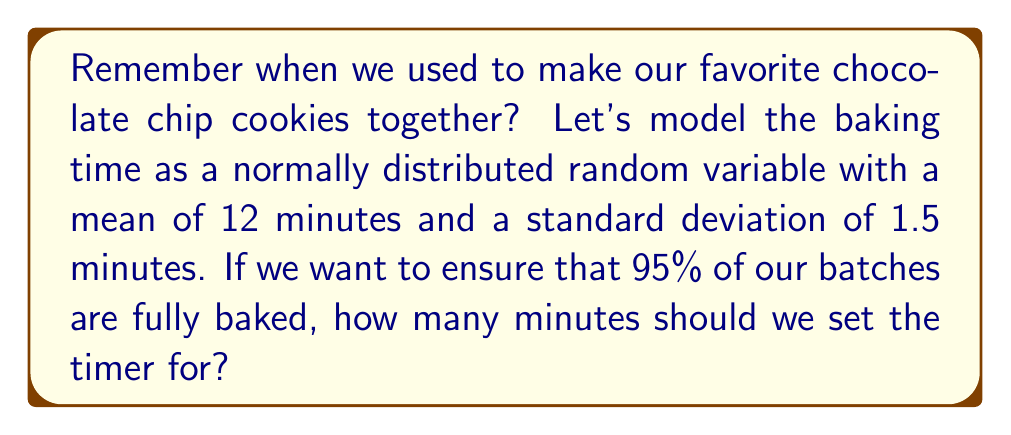Help me with this question. Let's approach this step-by-step:

1) We're dealing with a normal distribution where:
   $\mu = 12$ minutes (mean)
   $\sigma = 1.5$ minutes (standard deviation)

2) We want to find the time $t$ such that 95% of batches are fully baked. This means we're looking for the 95th percentile of the distribution.

3) In a normal distribution, the area under the curve from $-\infty$ to $\mu + z\sigma$ is given by $\Phi(z)$, where $\Phi$ is the standard normal cumulative distribution function.

4) We want $\Phi(z) = 0.95$

5) From a standard normal table or calculator, we find that $z \approx 1.645$ for $\Phi(z) = 0.95$

6) Now we can set up the equation:
   $t = \mu + z\sigma$

7) Plugging in our values:
   $t = 12 + 1.645 * 1.5$

8) Calculating:
   $t = 12 + 2.4675 = 14.4675$ minutes

9) Rounding up to ensure at least 95% are fully baked:
   $t \approx 14.47$ minutes
Answer: 14.47 minutes 